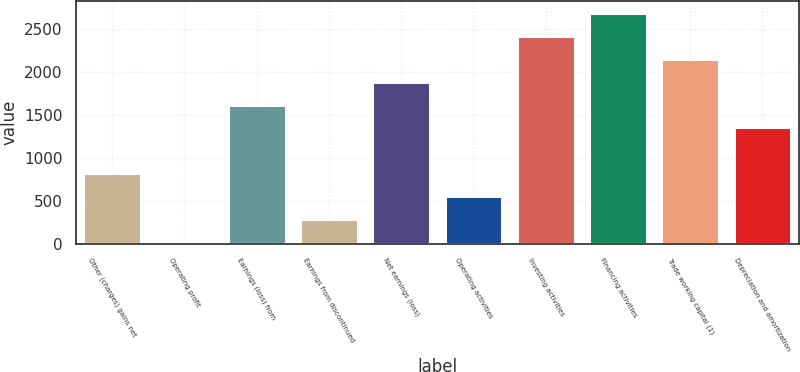Convert chart. <chart><loc_0><loc_0><loc_500><loc_500><bar_chart><fcel>Other (charges) gains net<fcel>Operating profit<fcel>Earnings (loss) from<fcel>Earnings from discontinued<fcel>Net earnings (loss)<fcel>Operating activities<fcel>Investing activities<fcel>Financing activities<fcel>Trade working capital (1)<fcel>Depreciation and amortization<nl><fcel>817.7<fcel>17<fcel>1618.4<fcel>283.9<fcel>1885.3<fcel>550.8<fcel>2419.1<fcel>2686<fcel>2152.2<fcel>1351.5<nl></chart> 